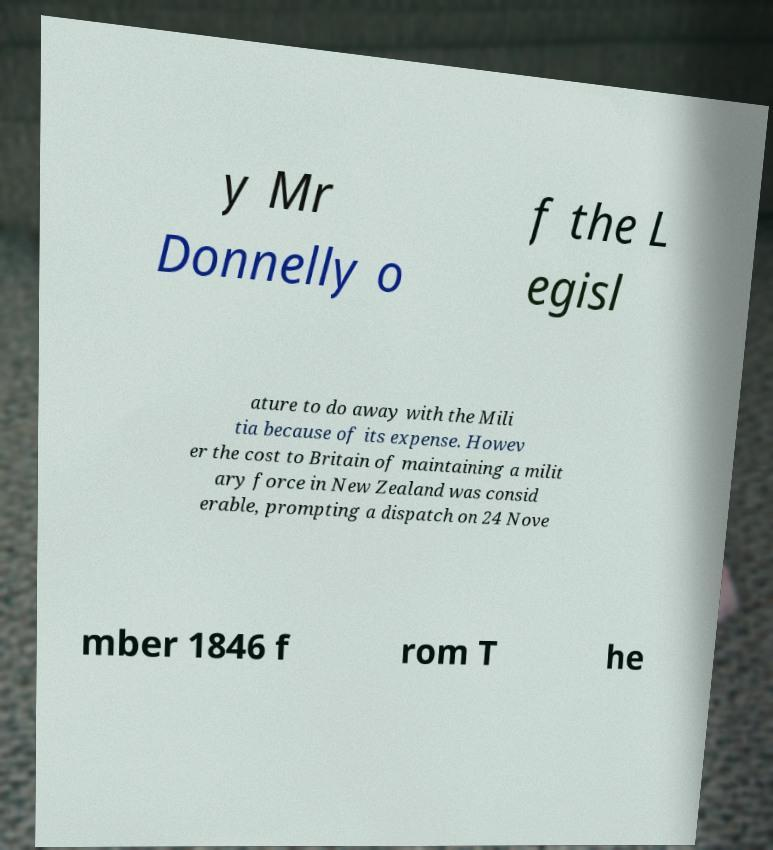Can you accurately transcribe the text from the provided image for me? y Mr Donnelly o f the L egisl ature to do away with the Mili tia because of its expense. Howev er the cost to Britain of maintaining a milit ary force in New Zealand was consid erable, prompting a dispatch on 24 Nove mber 1846 f rom T he 